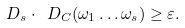Convert formula to latex. <formula><loc_0><loc_0><loc_500><loc_500>\ D _ { s } \cdot \ D _ { C } ( \omega _ { 1 } \dots \omega _ { s } ) \geq \varepsilon .</formula> 